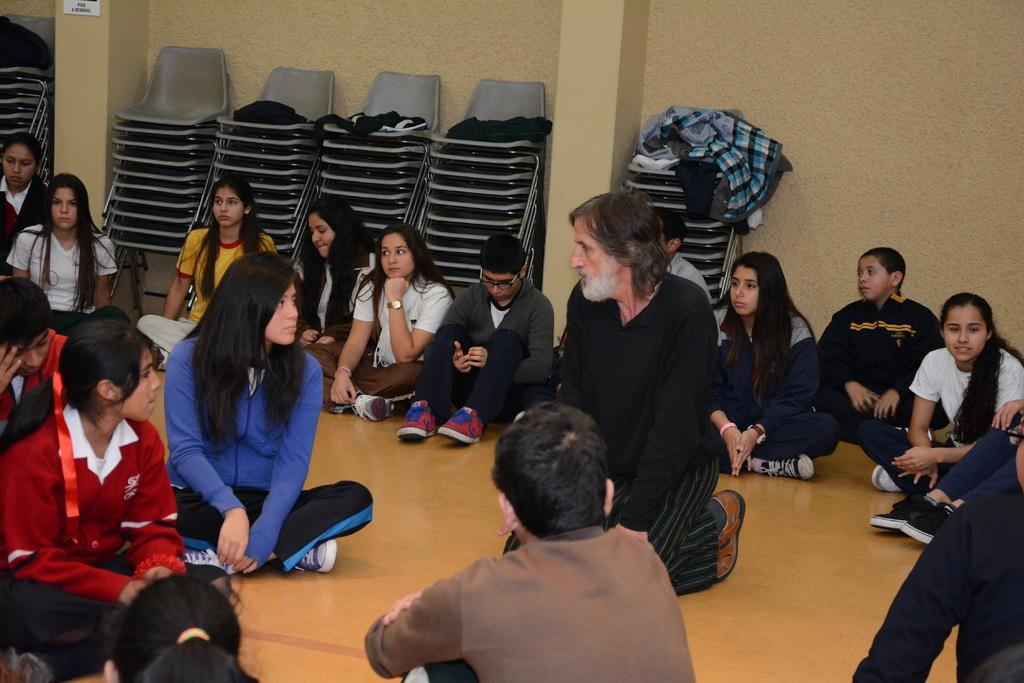How would you summarize this image in a sentence or two? In the picture, a group of people were sitting on the floor and there is a man laying on his knees in the center of those people and behind them there are many chairs and in the background there is a wall. 